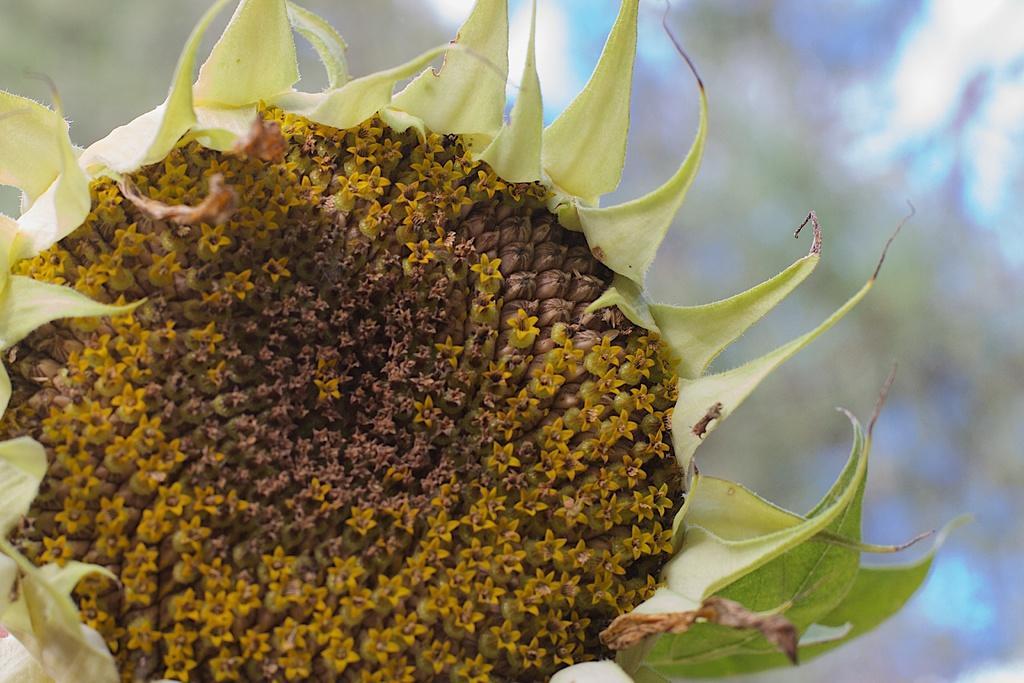In one or two sentences, can you explain what this image depicts? In this image I can see yellow and brown colour flower. I can also see green colour leaves and I can see this image is blurry from background. 